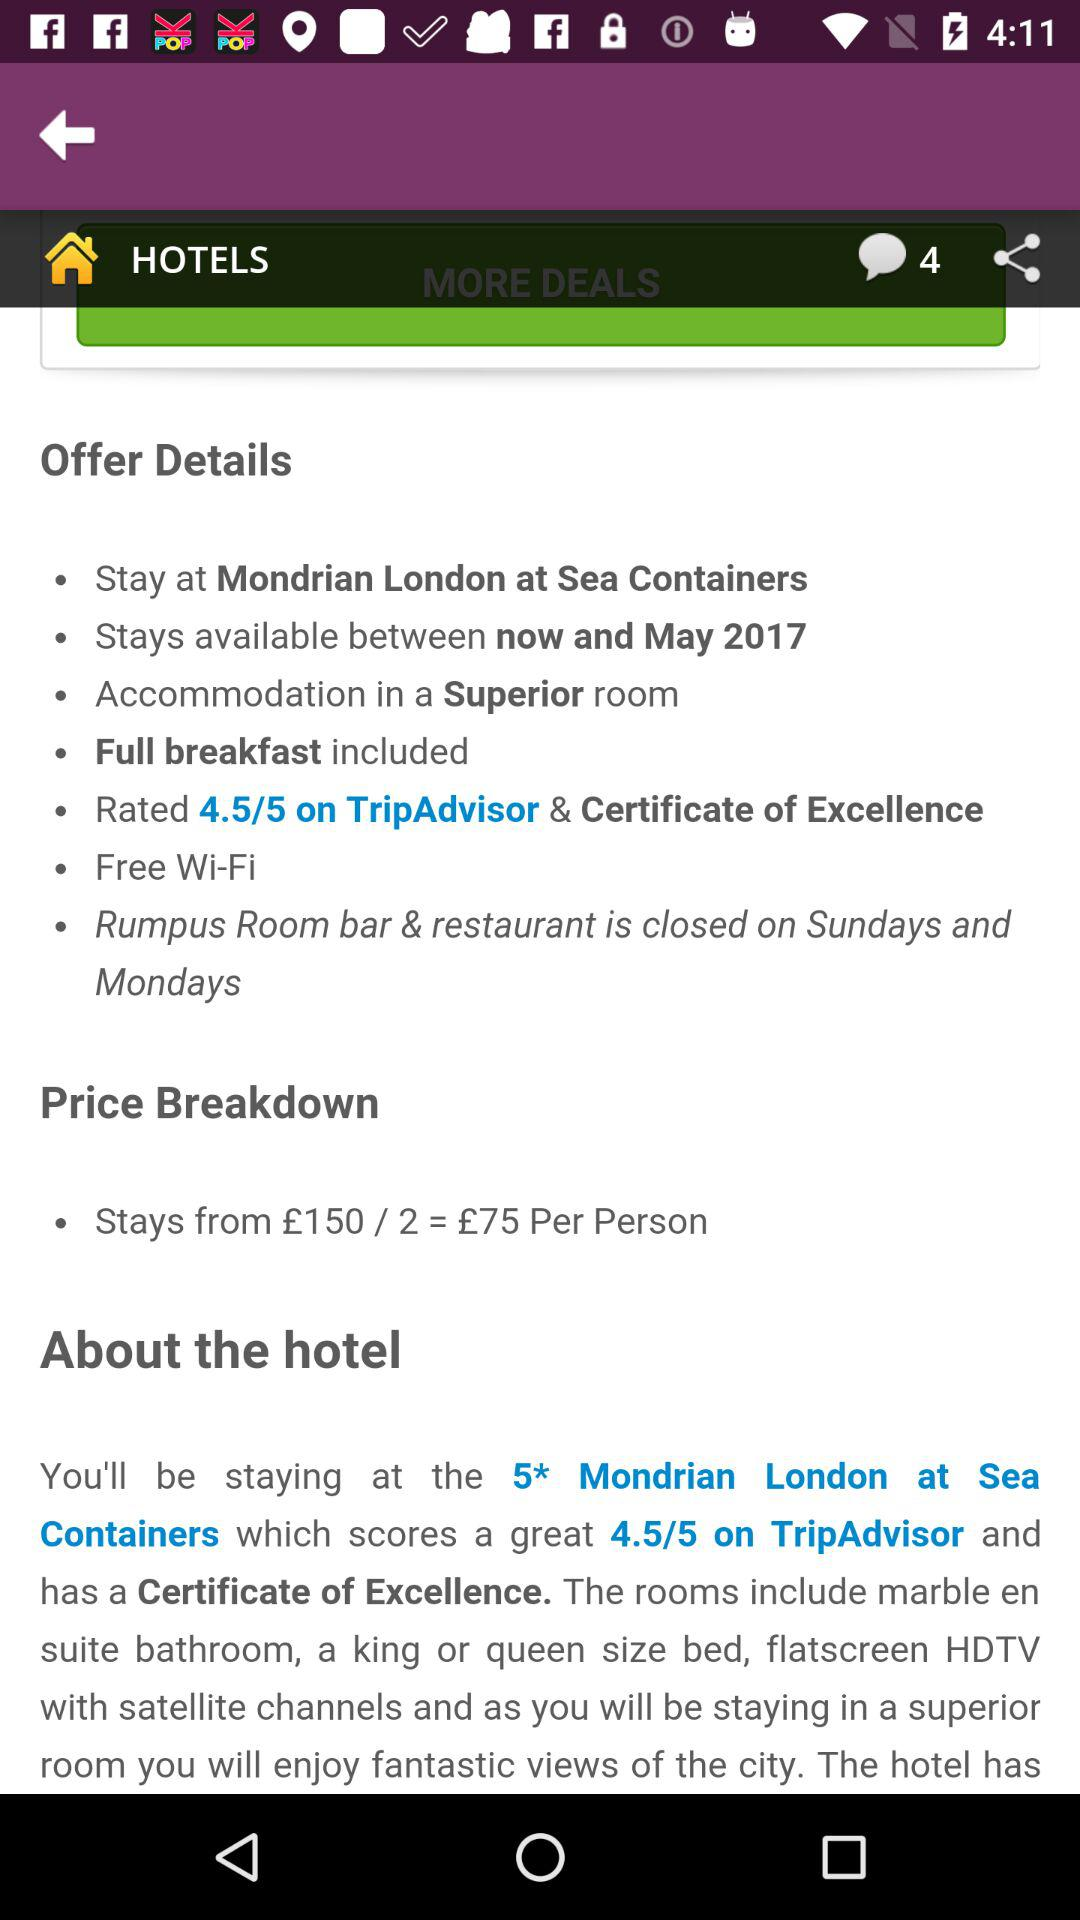What is the score of the hotel on TripAdvisor? The score is 4.5/5. 